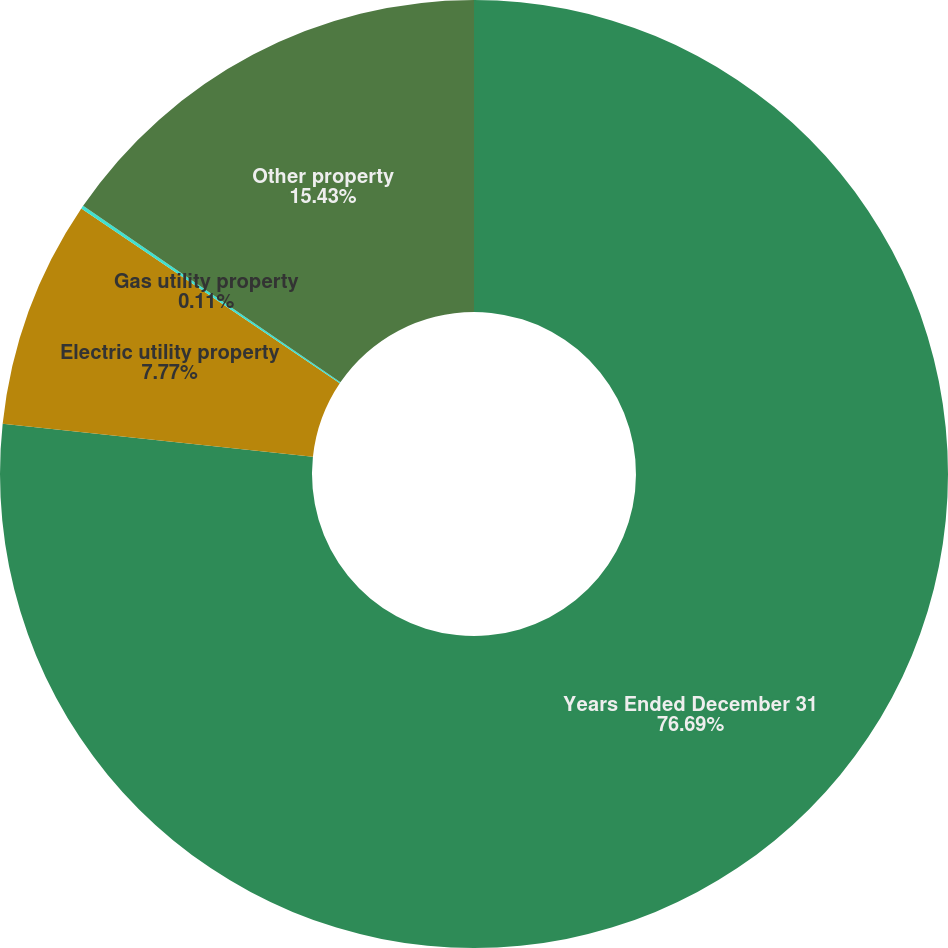Convert chart. <chart><loc_0><loc_0><loc_500><loc_500><pie_chart><fcel>Years Ended December 31<fcel>Electric utility property<fcel>Gas utility property<fcel>Other property<nl><fcel>76.69%<fcel>7.77%<fcel>0.11%<fcel>15.43%<nl></chart> 